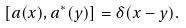Convert formula to latex. <formula><loc_0><loc_0><loc_500><loc_500>[ a ( x ) , a ^ { * } ( y ) ] = \delta ( x - y ) .</formula> 